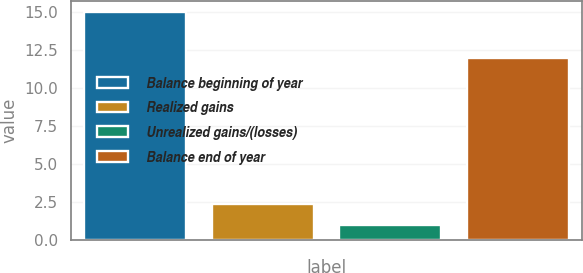<chart> <loc_0><loc_0><loc_500><loc_500><bar_chart><fcel>Balance beginning of year<fcel>Realized gains<fcel>Unrealized gains/(losses)<fcel>Balance end of year<nl><fcel>15<fcel>2.4<fcel>1<fcel>12<nl></chart> 